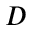Convert formula to latex. <formula><loc_0><loc_0><loc_500><loc_500>D</formula> 